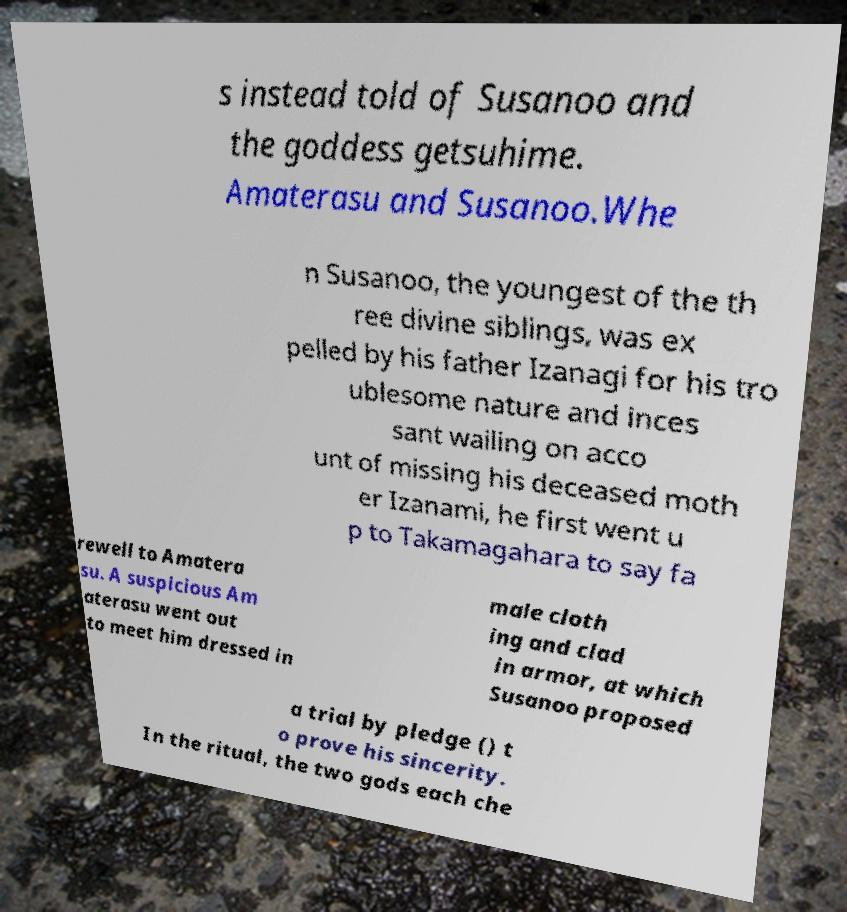What messages or text are displayed in this image? I need them in a readable, typed format. s instead told of Susanoo and the goddess getsuhime. Amaterasu and Susanoo.Whe n Susanoo, the youngest of the th ree divine siblings, was ex pelled by his father Izanagi for his tro ublesome nature and inces sant wailing on acco unt of missing his deceased moth er Izanami, he first went u p to Takamagahara to say fa rewell to Amatera su. A suspicious Am aterasu went out to meet him dressed in male cloth ing and clad in armor, at which Susanoo proposed a trial by pledge () t o prove his sincerity. In the ritual, the two gods each che 